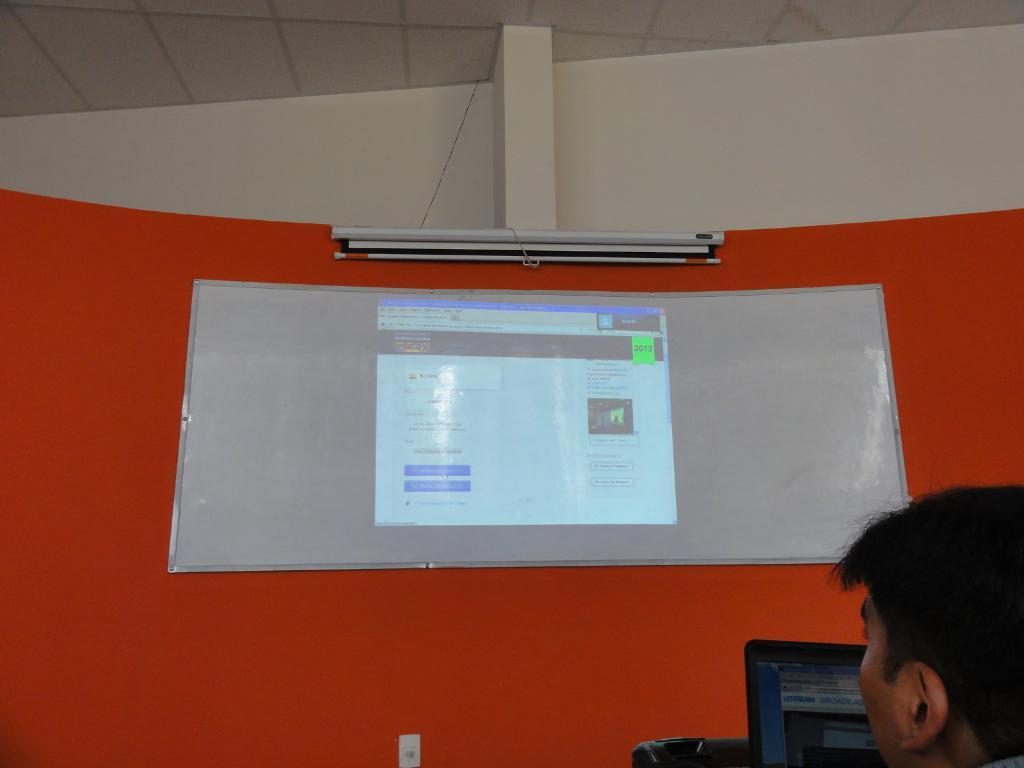What is on the wall in the image? There is a screen on the wall in the image. Who is present in the image? A person is visible in the image. What is the person holding? The person is holding a laptop. Where is the laptop positioned in relation to the person? The laptop is in front of the person. On which side of the image is the person located? The person is on the right side of the image. At what level of the image is the person situated? The person is at the bottom of the image. What type of prison is depicted in the image? There is no prison present in the image; it features a person holding a laptop in front of a screen on the wall. How many pieces of quartz can be seen in the image? There is no quartz present in the image. 